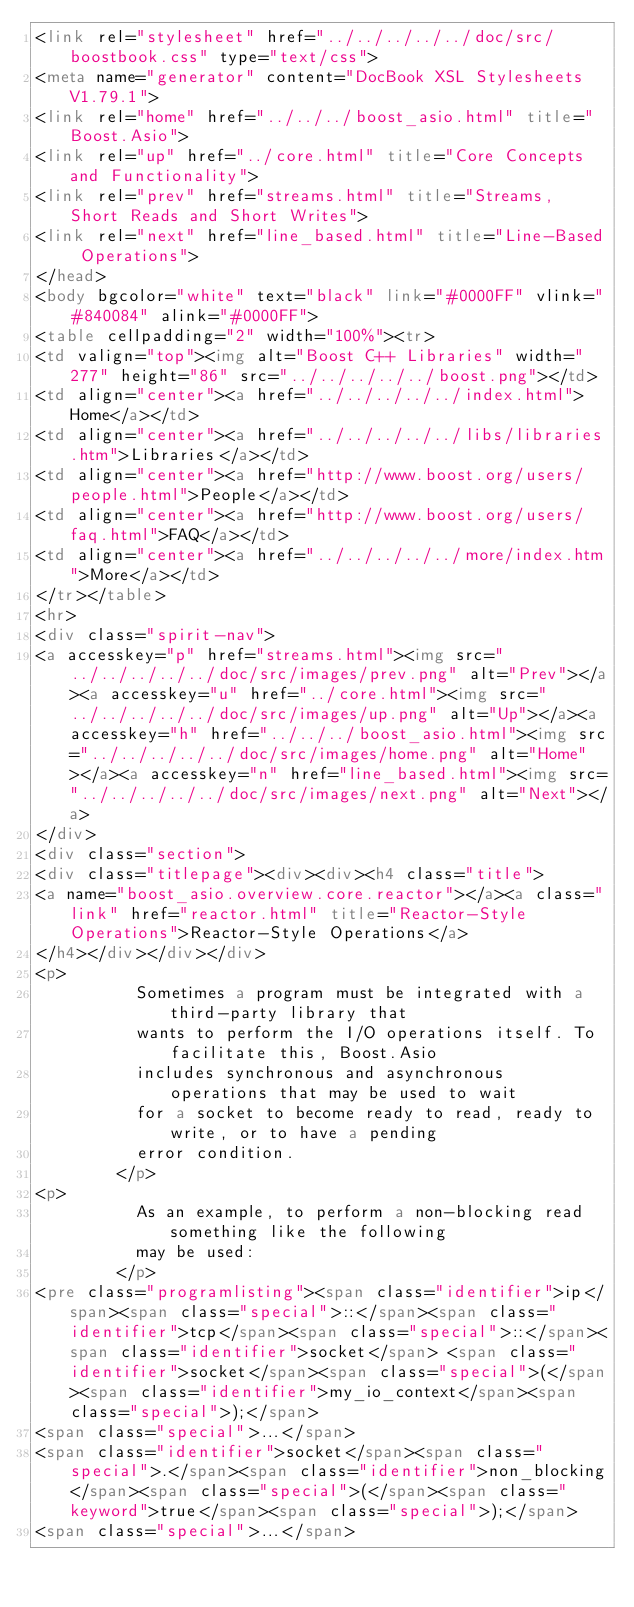<code> <loc_0><loc_0><loc_500><loc_500><_HTML_><link rel="stylesheet" href="../../../../../doc/src/boostbook.css" type="text/css">
<meta name="generator" content="DocBook XSL Stylesheets V1.79.1">
<link rel="home" href="../../../boost_asio.html" title="Boost.Asio">
<link rel="up" href="../core.html" title="Core Concepts and Functionality">
<link rel="prev" href="streams.html" title="Streams, Short Reads and Short Writes">
<link rel="next" href="line_based.html" title="Line-Based Operations">
</head>
<body bgcolor="white" text="black" link="#0000FF" vlink="#840084" alink="#0000FF">
<table cellpadding="2" width="100%"><tr>
<td valign="top"><img alt="Boost C++ Libraries" width="277" height="86" src="../../../../../boost.png"></td>
<td align="center"><a href="../../../../../index.html">Home</a></td>
<td align="center"><a href="../../../../../libs/libraries.htm">Libraries</a></td>
<td align="center"><a href="http://www.boost.org/users/people.html">People</a></td>
<td align="center"><a href="http://www.boost.org/users/faq.html">FAQ</a></td>
<td align="center"><a href="../../../../../more/index.htm">More</a></td>
</tr></table>
<hr>
<div class="spirit-nav">
<a accesskey="p" href="streams.html"><img src="../../../../../doc/src/images/prev.png" alt="Prev"></a><a accesskey="u" href="../core.html"><img src="../../../../../doc/src/images/up.png" alt="Up"></a><a accesskey="h" href="../../../boost_asio.html"><img src="../../../../../doc/src/images/home.png" alt="Home"></a><a accesskey="n" href="line_based.html"><img src="../../../../../doc/src/images/next.png" alt="Next"></a>
</div>
<div class="section">
<div class="titlepage"><div><div><h4 class="title">
<a name="boost_asio.overview.core.reactor"></a><a class="link" href="reactor.html" title="Reactor-Style Operations">Reactor-Style Operations</a>
</h4></div></div></div>
<p>
          Sometimes a program must be integrated with a third-party library that
          wants to perform the I/O operations itself. To facilitate this, Boost.Asio
          includes synchronous and asynchronous operations that may be used to wait
          for a socket to become ready to read, ready to write, or to have a pending
          error condition.
        </p>
<p>
          As an example, to perform a non-blocking read something like the following
          may be used:
        </p>
<pre class="programlisting"><span class="identifier">ip</span><span class="special">::</span><span class="identifier">tcp</span><span class="special">::</span><span class="identifier">socket</span> <span class="identifier">socket</span><span class="special">(</span><span class="identifier">my_io_context</span><span class="special">);</span>
<span class="special">...</span>
<span class="identifier">socket</span><span class="special">.</span><span class="identifier">non_blocking</span><span class="special">(</span><span class="keyword">true</span><span class="special">);</span>
<span class="special">...</span></code> 